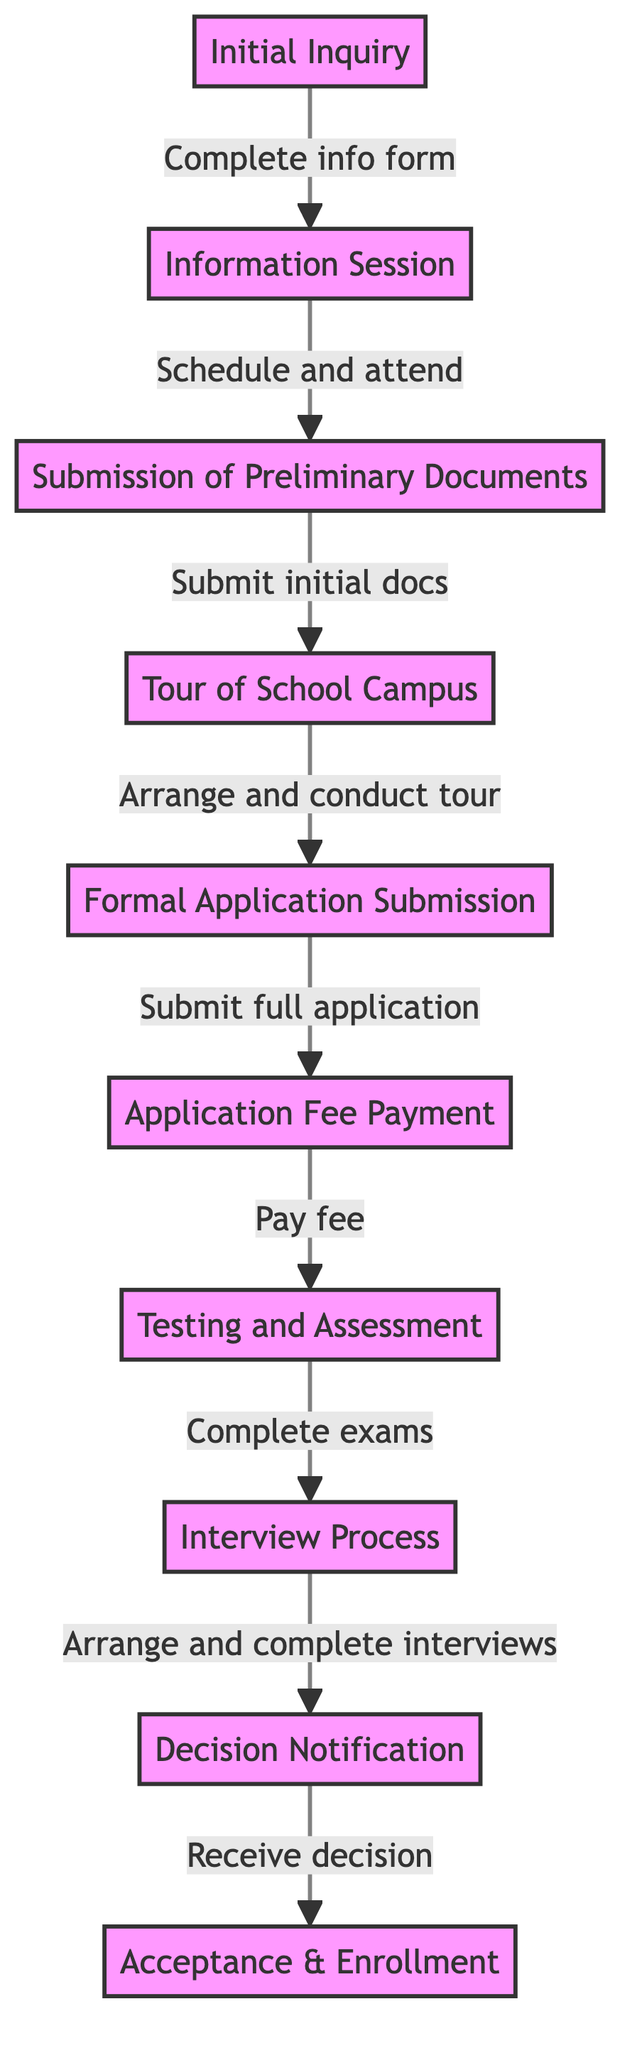What is the first step in the application process? The diagram starts with the "Initial Inquiry" step, which is the first action families take by contacting the school for information.
Answer: Initial Inquiry How many steps are in the application workflow? Counting the individual steps listed in the diagram shows there are 10 steps from the initial inquiry to acceptance and enrollment.
Answer: 10 What do families need to do after attending the information session? After attending the information session, the next step requires families to submit preliminary documents by filling out an inquiry form and submitting initial documentation.
Answer: Submission of Preliminary Documents What action follows the formal application submission? After submitting the formal application, the next action required is the payment of the application fee. This is represented as a direct transition from the "Formal Application Submission" node to the "Application Fee Payment" node.
Answer: Application Fee Payment What is needed before proceeding to the interview process? Before moving on to the interview process, families must complete standardized testing or individual assessments, as indicated in the diagram.
Answer: Testing and Assessment How does the process flow after the decision notification? The process continues to "Acceptance & Enrollment" after the decision notification step, meaning families will sign contracts and submit deposits once they receive their admission decision.
Answer: Acceptance & Enrollment Which step involves campus tours? The step that involves campus tours is labeled "Tour of School Campus," where families are invited to tour the school. This step follows the preliminary document submission.
Answer: Tour of School Campus What is the relationship between the "Information Session" and "Submission of Preliminary Documents"? The relationship is that families must attend the "Information Session" before they can move on to the "Submission of Preliminary Documents" step. This demonstrates a sequential dependency in the workflow.
Answer: Sequential dependency What must families do after receiving the admission decision? After receiving the admission decision, families are required to complete enrollment paperwork and pay deposits, indicating the transition from decision notification to acceptance and enrollment.
Answer: Complete enrollment paperwork In which step do families pay the application fee? Families pay the application fee in the "Application Fee Payment" step, which comes right after the formal application submission.
Answer: Application Fee Payment 